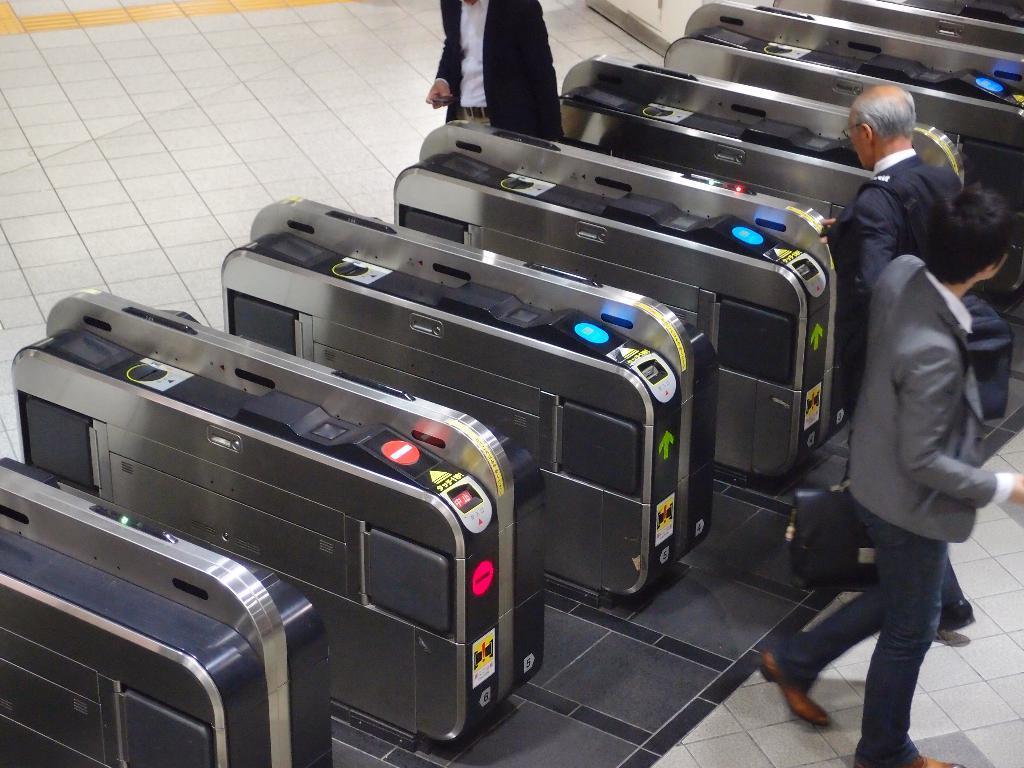Please provide a concise description of this image. In this image i can see three men walking at the left there are few machines. 